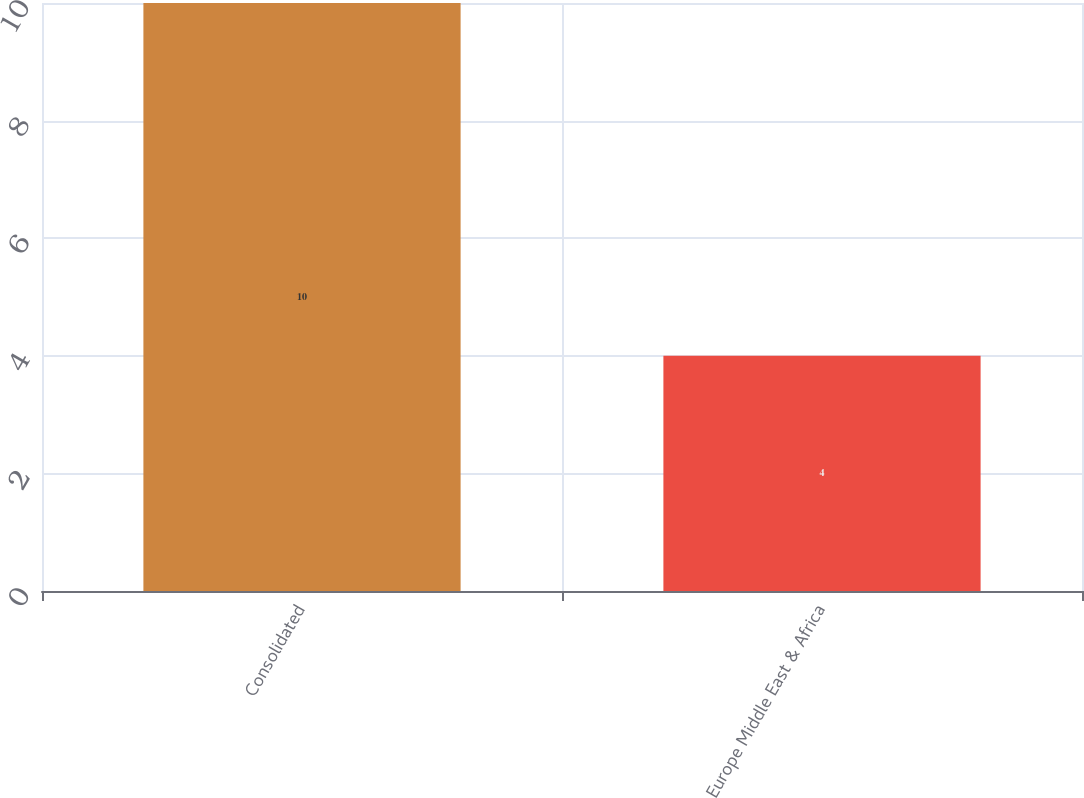<chart> <loc_0><loc_0><loc_500><loc_500><bar_chart><fcel>Consolidated<fcel>Europe Middle East & Africa<nl><fcel>10<fcel>4<nl></chart> 